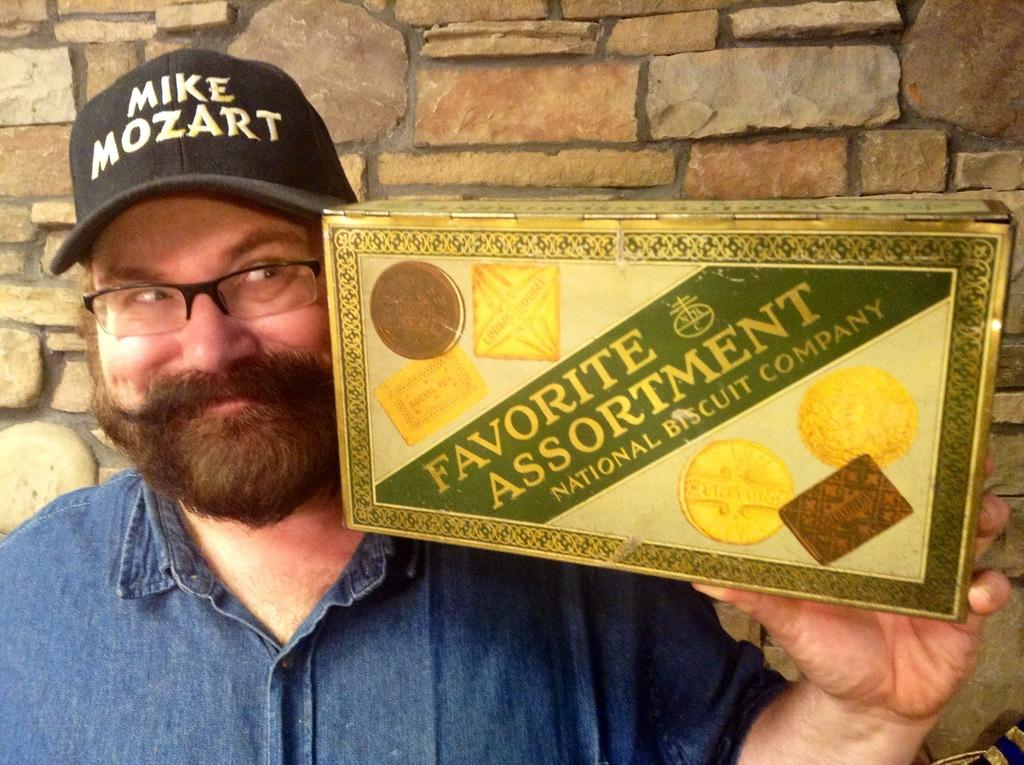What is the position of the man in the image? The man is standing on the left side of the image. What accessories is the man wearing? The man is wearing spectacles and a cap. What is the man holding in the image? The man is holding a box. What can be seen in the background of the image? There is a wall visible in the background of the image. How does the man increase his profit in the image? There is no information about profit or any financial activity in the image. The man is simply standing, wearing accessories, and holding a box. 